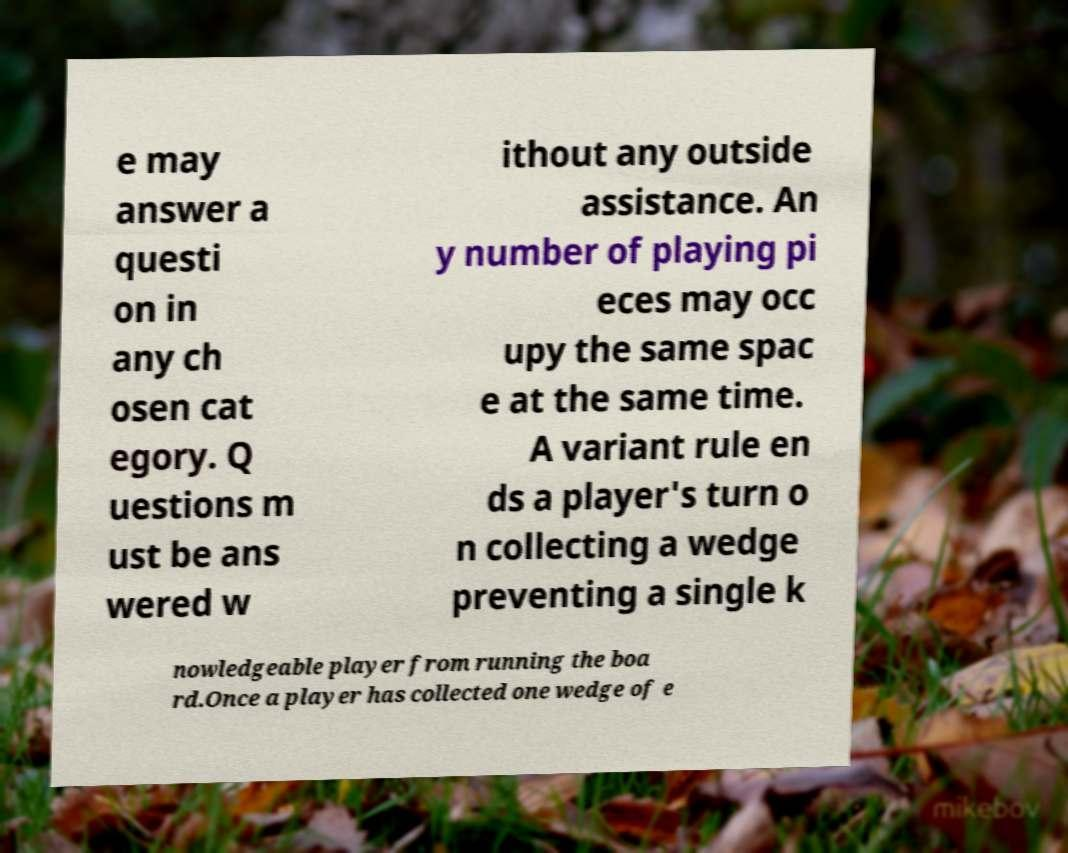For documentation purposes, I need the text within this image transcribed. Could you provide that? e may answer a questi on in any ch osen cat egory. Q uestions m ust be ans wered w ithout any outside assistance. An y number of playing pi eces may occ upy the same spac e at the same time. A variant rule en ds a player's turn o n collecting a wedge preventing a single k nowledgeable player from running the boa rd.Once a player has collected one wedge of e 